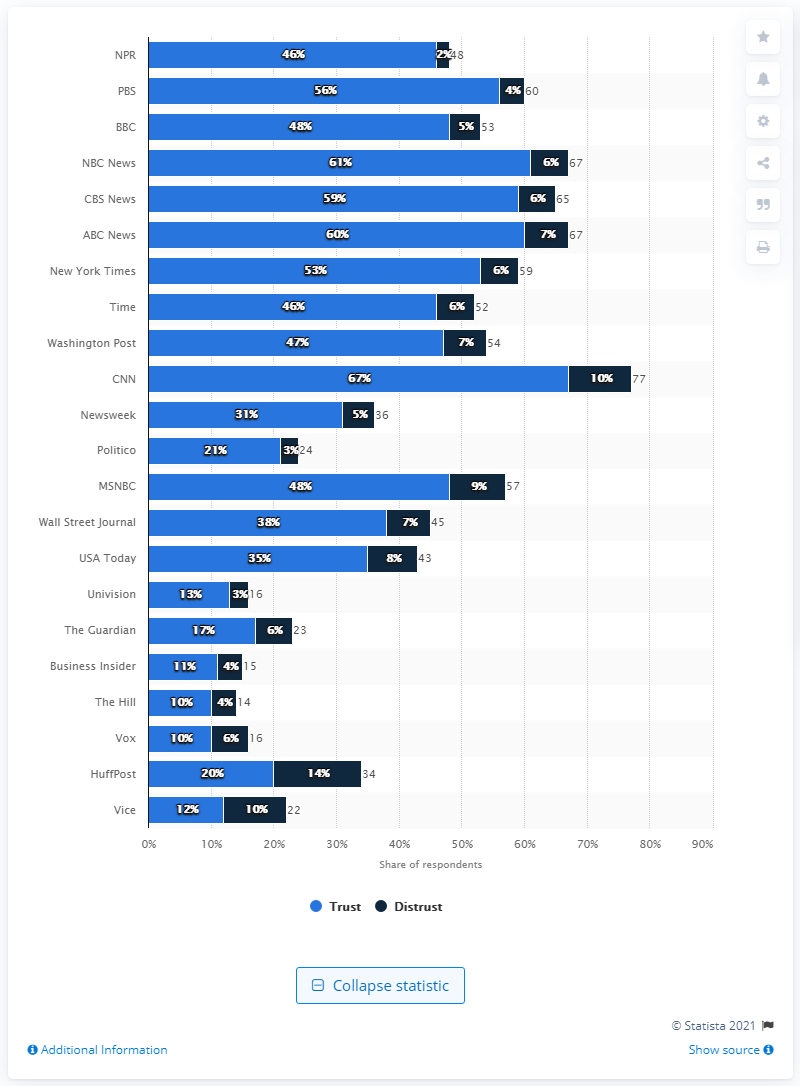Draw attention to some important aspects in this diagram. NBC News was the second most trusted political news source among Democrats. 